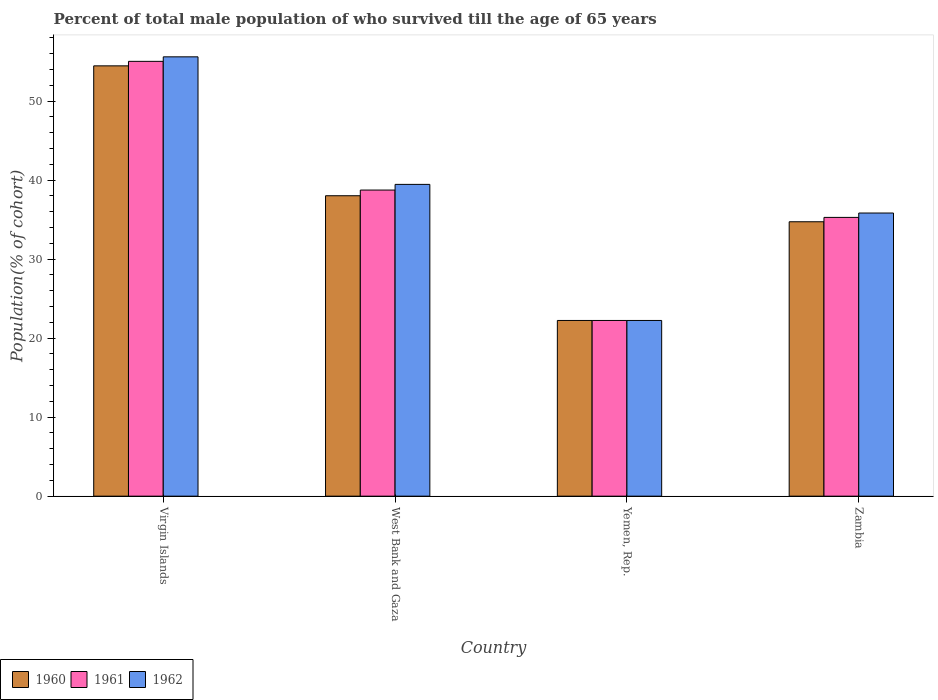How many different coloured bars are there?
Give a very brief answer. 3. How many groups of bars are there?
Provide a succinct answer. 4. How many bars are there on the 2nd tick from the left?
Your answer should be very brief. 3. How many bars are there on the 1st tick from the right?
Make the answer very short. 3. What is the label of the 4th group of bars from the left?
Provide a succinct answer. Zambia. What is the percentage of total male population who survived till the age of 65 years in 1960 in Virgin Islands?
Offer a terse response. 54.45. Across all countries, what is the maximum percentage of total male population who survived till the age of 65 years in 1961?
Your response must be concise. 55.02. Across all countries, what is the minimum percentage of total male population who survived till the age of 65 years in 1960?
Provide a short and direct response. 22.23. In which country was the percentage of total male population who survived till the age of 65 years in 1961 maximum?
Your answer should be very brief. Virgin Islands. In which country was the percentage of total male population who survived till the age of 65 years in 1961 minimum?
Your answer should be compact. Yemen, Rep. What is the total percentage of total male population who survived till the age of 65 years in 1962 in the graph?
Give a very brief answer. 153.1. What is the difference between the percentage of total male population who survived till the age of 65 years in 1962 in Yemen, Rep. and that in Zambia?
Your answer should be very brief. -13.59. What is the difference between the percentage of total male population who survived till the age of 65 years in 1962 in West Bank and Gaza and the percentage of total male population who survived till the age of 65 years in 1961 in Virgin Islands?
Your answer should be compact. -15.57. What is the average percentage of total male population who survived till the age of 65 years in 1960 per country?
Offer a very short reply. 37.36. What is the difference between the percentage of total male population who survived till the age of 65 years of/in 1962 and percentage of total male population who survived till the age of 65 years of/in 1961 in Virgin Islands?
Your answer should be compact. 0.57. In how many countries, is the percentage of total male population who survived till the age of 65 years in 1961 greater than 28 %?
Offer a terse response. 3. What is the ratio of the percentage of total male population who survived till the age of 65 years in 1960 in Virgin Islands to that in West Bank and Gaza?
Provide a short and direct response. 1.43. What is the difference between the highest and the second highest percentage of total male population who survived till the age of 65 years in 1962?
Provide a short and direct response. -3.62. What is the difference between the highest and the lowest percentage of total male population who survived till the age of 65 years in 1962?
Your response must be concise. 33.36. In how many countries, is the percentage of total male population who survived till the age of 65 years in 1960 greater than the average percentage of total male population who survived till the age of 65 years in 1960 taken over all countries?
Make the answer very short. 2. How many bars are there?
Your response must be concise. 12. What is the difference between two consecutive major ticks on the Y-axis?
Make the answer very short. 10. Does the graph contain any zero values?
Your answer should be compact. No. Does the graph contain grids?
Provide a short and direct response. No. Where does the legend appear in the graph?
Offer a very short reply. Bottom left. How many legend labels are there?
Offer a terse response. 3. What is the title of the graph?
Offer a terse response. Percent of total male population of who survived till the age of 65 years. What is the label or title of the X-axis?
Provide a succinct answer. Country. What is the label or title of the Y-axis?
Your answer should be very brief. Population(% of cohort). What is the Population(% of cohort) in 1960 in Virgin Islands?
Offer a terse response. 54.45. What is the Population(% of cohort) of 1961 in Virgin Islands?
Provide a short and direct response. 55.02. What is the Population(% of cohort) in 1962 in Virgin Islands?
Provide a short and direct response. 55.59. What is the Population(% of cohort) in 1960 in West Bank and Gaza?
Your answer should be very brief. 38.02. What is the Population(% of cohort) in 1961 in West Bank and Gaza?
Make the answer very short. 38.73. What is the Population(% of cohort) of 1962 in West Bank and Gaza?
Your answer should be very brief. 39.45. What is the Population(% of cohort) of 1960 in Yemen, Rep.?
Give a very brief answer. 22.23. What is the Population(% of cohort) in 1961 in Yemen, Rep.?
Provide a succinct answer. 22.23. What is the Population(% of cohort) of 1962 in Yemen, Rep.?
Your answer should be very brief. 22.23. What is the Population(% of cohort) in 1960 in Zambia?
Keep it short and to the point. 34.72. What is the Population(% of cohort) of 1961 in Zambia?
Make the answer very short. 35.28. What is the Population(% of cohort) in 1962 in Zambia?
Keep it short and to the point. 35.83. Across all countries, what is the maximum Population(% of cohort) of 1960?
Make the answer very short. 54.45. Across all countries, what is the maximum Population(% of cohort) of 1961?
Offer a very short reply. 55.02. Across all countries, what is the maximum Population(% of cohort) of 1962?
Your response must be concise. 55.59. Across all countries, what is the minimum Population(% of cohort) in 1960?
Give a very brief answer. 22.23. Across all countries, what is the minimum Population(% of cohort) of 1961?
Keep it short and to the point. 22.23. Across all countries, what is the minimum Population(% of cohort) of 1962?
Provide a short and direct response. 22.23. What is the total Population(% of cohort) in 1960 in the graph?
Provide a succinct answer. 149.42. What is the total Population(% of cohort) in 1961 in the graph?
Your answer should be compact. 151.26. What is the total Population(% of cohort) of 1962 in the graph?
Give a very brief answer. 153.1. What is the difference between the Population(% of cohort) of 1960 in Virgin Islands and that in West Bank and Gaza?
Your answer should be very brief. 16.44. What is the difference between the Population(% of cohort) of 1961 in Virgin Islands and that in West Bank and Gaza?
Give a very brief answer. 16.29. What is the difference between the Population(% of cohort) of 1962 in Virgin Islands and that in West Bank and Gaza?
Give a very brief answer. 16.14. What is the difference between the Population(% of cohort) of 1960 in Virgin Islands and that in Yemen, Rep.?
Your response must be concise. 32.22. What is the difference between the Population(% of cohort) of 1961 in Virgin Islands and that in Yemen, Rep.?
Make the answer very short. 32.79. What is the difference between the Population(% of cohort) of 1962 in Virgin Islands and that in Yemen, Rep.?
Your answer should be very brief. 33.36. What is the difference between the Population(% of cohort) of 1960 in Virgin Islands and that in Zambia?
Provide a succinct answer. 19.73. What is the difference between the Population(% of cohort) of 1961 in Virgin Islands and that in Zambia?
Provide a short and direct response. 19.75. What is the difference between the Population(% of cohort) of 1962 in Virgin Islands and that in Zambia?
Your answer should be compact. 19.76. What is the difference between the Population(% of cohort) in 1960 in West Bank and Gaza and that in Yemen, Rep.?
Ensure brevity in your answer.  15.78. What is the difference between the Population(% of cohort) of 1961 in West Bank and Gaza and that in Yemen, Rep.?
Provide a short and direct response. 16.5. What is the difference between the Population(% of cohort) of 1962 in West Bank and Gaza and that in Yemen, Rep.?
Provide a short and direct response. 17.22. What is the difference between the Population(% of cohort) of 1960 in West Bank and Gaza and that in Zambia?
Offer a terse response. 3.29. What is the difference between the Population(% of cohort) of 1961 in West Bank and Gaza and that in Zambia?
Your answer should be very brief. 3.46. What is the difference between the Population(% of cohort) of 1962 in West Bank and Gaza and that in Zambia?
Offer a very short reply. 3.62. What is the difference between the Population(% of cohort) of 1960 in Yemen, Rep. and that in Zambia?
Provide a succinct answer. -12.49. What is the difference between the Population(% of cohort) of 1961 in Yemen, Rep. and that in Zambia?
Your response must be concise. -13.04. What is the difference between the Population(% of cohort) of 1962 in Yemen, Rep. and that in Zambia?
Offer a very short reply. -13.59. What is the difference between the Population(% of cohort) of 1960 in Virgin Islands and the Population(% of cohort) of 1961 in West Bank and Gaza?
Keep it short and to the point. 15.72. What is the difference between the Population(% of cohort) of 1960 in Virgin Islands and the Population(% of cohort) of 1962 in West Bank and Gaza?
Provide a short and direct response. 15. What is the difference between the Population(% of cohort) in 1961 in Virgin Islands and the Population(% of cohort) in 1962 in West Bank and Gaza?
Provide a short and direct response. 15.57. What is the difference between the Population(% of cohort) in 1960 in Virgin Islands and the Population(% of cohort) in 1961 in Yemen, Rep.?
Your answer should be compact. 32.22. What is the difference between the Population(% of cohort) of 1960 in Virgin Islands and the Population(% of cohort) of 1962 in Yemen, Rep.?
Provide a succinct answer. 32.22. What is the difference between the Population(% of cohort) of 1961 in Virgin Islands and the Population(% of cohort) of 1962 in Yemen, Rep.?
Offer a terse response. 32.79. What is the difference between the Population(% of cohort) of 1960 in Virgin Islands and the Population(% of cohort) of 1961 in Zambia?
Provide a succinct answer. 19.18. What is the difference between the Population(% of cohort) in 1960 in Virgin Islands and the Population(% of cohort) in 1962 in Zambia?
Offer a very short reply. 18.62. What is the difference between the Population(% of cohort) in 1961 in Virgin Islands and the Population(% of cohort) in 1962 in Zambia?
Your response must be concise. 19.19. What is the difference between the Population(% of cohort) in 1960 in West Bank and Gaza and the Population(% of cohort) in 1961 in Yemen, Rep.?
Your response must be concise. 15.78. What is the difference between the Population(% of cohort) of 1960 in West Bank and Gaza and the Population(% of cohort) of 1962 in Yemen, Rep.?
Give a very brief answer. 15.78. What is the difference between the Population(% of cohort) in 1961 in West Bank and Gaza and the Population(% of cohort) in 1962 in Yemen, Rep.?
Give a very brief answer. 16.5. What is the difference between the Population(% of cohort) of 1960 in West Bank and Gaza and the Population(% of cohort) of 1961 in Zambia?
Offer a very short reply. 2.74. What is the difference between the Population(% of cohort) in 1960 in West Bank and Gaza and the Population(% of cohort) in 1962 in Zambia?
Give a very brief answer. 2.19. What is the difference between the Population(% of cohort) in 1961 in West Bank and Gaza and the Population(% of cohort) in 1962 in Zambia?
Ensure brevity in your answer.  2.91. What is the difference between the Population(% of cohort) of 1960 in Yemen, Rep. and the Population(% of cohort) of 1961 in Zambia?
Your answer should be compact. -13.04. What is the difference between the Population(% of cohort) in 1960 in Yemen, Rep. and the Population(% of cohort) in 1962 in Zambia?
Make the answer very short. -13.59. What is the difference between the Population(% of cohort) in 1961 in Yemen, Rep. and the Population(% of cohort) in 1962 in Zambia?
Your answer should be very brief. -13.59. What is the average Population(% of cohort) of 1960 per country?
Offer a very short reply. 37.36. What is the average Population(% of cohort) in 1961 per country?
Provide a short and direct response. 37.82. What is the average Population(% of cohort) of 1962 per country?
Offer a terse response. 38.28. What is the difference between the Population(% of cohort) of 1960 and Population(% of cohort) of 1961 in Virgin Islands?
Your response must be concise. -0.57. What is the difference between the Population(% of cohort) in 1960 and Population(% of cohort) in 1962 in Virgin Islands?
Your answer should be compact. -1.14. What is the difference between the Population(% of cohort) in 1961 and Population(% of cohort) in 1962 in Virgin Islands?
Provide a short and direct response. -0.57. What is the difference between the Population(% of cohort) of 1960 and Population(% of cohort) of 1961 in West Bank and Gaza?
Your answer should be compact. -0.72. What is the difference between the Population(% of cohort) in 1960 and Population(% of cohort) in 1962 in West Bank and Gaza?
Your answer should be compact. -1.44. What is the difference between the Population(% of cohort) of 1961 and Population(% of cohort) of 1962 in West Bank and Gaza?
Your response must be concise. -0.72. What is the difference between the Population(% of cohort) in 1960 and Population(% of cohort) in 1961 in Yemen, Rep.?
Ensure brevity in your answer.  0. What is the difference between the Population(% of cohort) in 1960 and Population(% of cohort) in 1961 in Zambia?
Provide a short and direct response. -0.55. What is the difference between the Population(% of cohort) of 1960 and Population(% of cohort) of 1962 in Zambia?
Provide a short and direct response. -1.11. What is the difference between the Population(% of cohort) in 1961 and Population(% of cohort) in 1962 in Zambia?
Offer a terse response. -0.55. What is the ratio of the Population(% of cohort) in 1960 in Virgin Islands to that in West Bank and Gaza?
Offer a terse response. 1.43. What is the ratio of the Population(% of cohort) of 1961 in Virgin Islands to that in West Bank and Gaza?
Your answer should be very brief. 1.42. What is the ratio of the Population(% of cohort) in 1962 in Virgin Islands to that in West Bank and Gaza?
Offer a very short reply. 1.41. What is the ratio of the Population(% of cohort) of 1960 in Virgin Islands to that in Yemen, Rep.?
Your response must be concise. 2.45. What is the ratio of the Population(% of cohort) in 1961 in Virgin Islands to that in Yemen, Rep.?
Provide a succinct answer. 2.47. What is the ratio of the Population(% of cohort) of 1962 in Virgin Islands to that in Yemen, Rep.?
Keep it short and to the point. 2.5. What is the ratio of the Population(% of cohort) in 1960 in Virgin Islands to that in Zambia?
Provide a short and direct response. 1.57. What is the ratio of the Population(% of cohort) of 1961 in Virgin Islands to that in Zambia?
Ensure brevity in your answer.  1.56. What is the ratio of the Population(% of cohort) of 1962 in Virgin Islands to that in Zambia?
Your response must be concise. 1.55. What is the ratio of the Population(% of cohort) of 1960 in West Bank and Gaza to that in Yemen, Rep.?
Offer a terse response. 1.71. What is the ratio of the Population(% of cohort) of 1961 in West Bank and Gaza to that in Yemen, Rep.?
Give a very brief answer. 1.74. What is the ratio of the Population(% of cohort) of 1962 in West Bank and Gaza to that in Yemen, Rep.?
Your answer should be very brief. 1.77. What is the ratio of the Population(% of cohort) in 1960 in West Bank and Gaza to that in Zambia?
Provide a short and direct response. 1.09. What is the ratio of the Population(% of cohort) in 1961 in West Bank and Gaza to that in Zambia?
Offer a very short reply. 1.1. What is the ratio of the Population(% of cohort) in 1962 in West Bank and Gaza to that in Zambia?
Provide a succinct answer. 1.1. What is the ratio of the Population(% of cohort) in 1960 in Yemen, Rep. to that in Zambia?
Give a very brief answer. 0.64. What is the ratio of the Population(% of cohort) in 1961 in Yemen, Rep. to that in Zambia?
Offer a very short reply. 0.63. What is the ratio of the Population(% of cohort) in 1962 in Yemen, Rep. to that in Zambia?
Provide a succinct answer. 0.62. What is the difference between the highest and the second highest Population(% of cohort) of 1960?
Offer a very short reply. 16.44. What is the difference between the highest and the second highest Population(% of cohort) of 1961?
Provide a succinct answer. 16.29. What is the difference between the highest and the second highest Population(% of cohort) of 1962?
Provide a succinct answer. 16.14. What is the difference between the highest and the lowest Population(% of cohort) in 1960?
Your response must be concise. 32.22. What is the difference between the highest and the lowest Population(% of cohort) of 1961?
Your answer should be very brief. 32.79. What is the difference between the highest and the lowest Population(% of cohort) of 1962?
Offer a terse response. 33.36. 